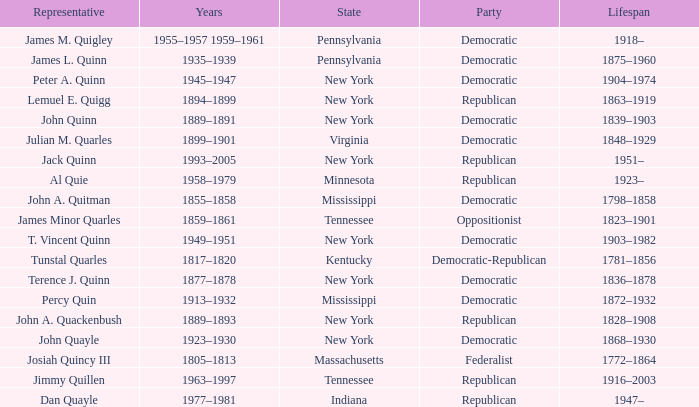Which state does Jimmy Quillen represent? Tennessee. 